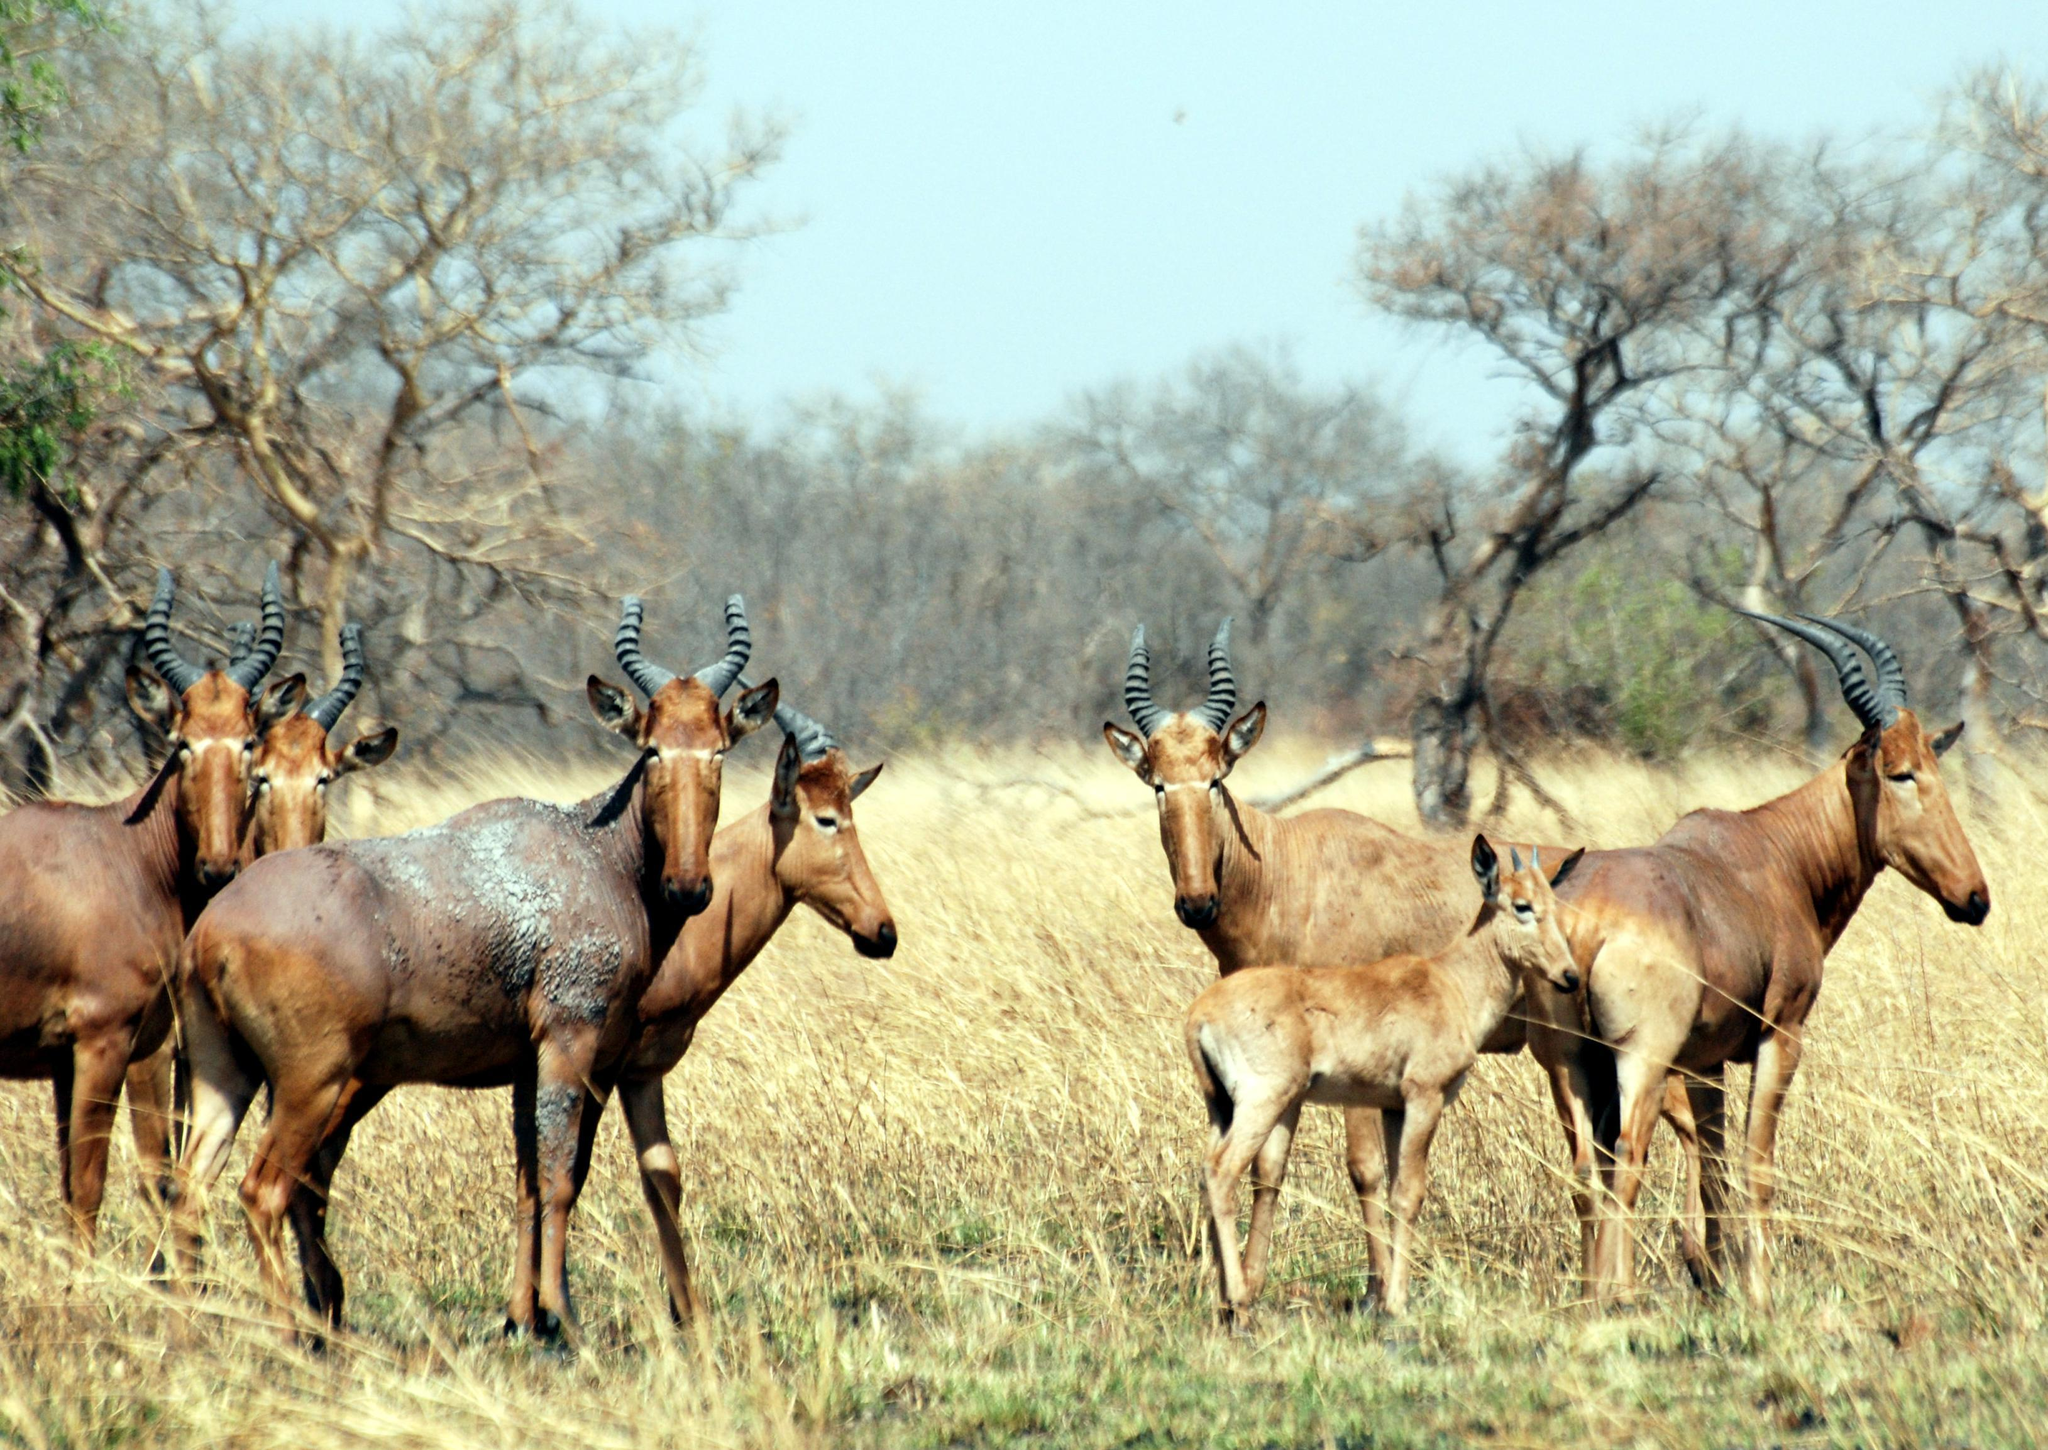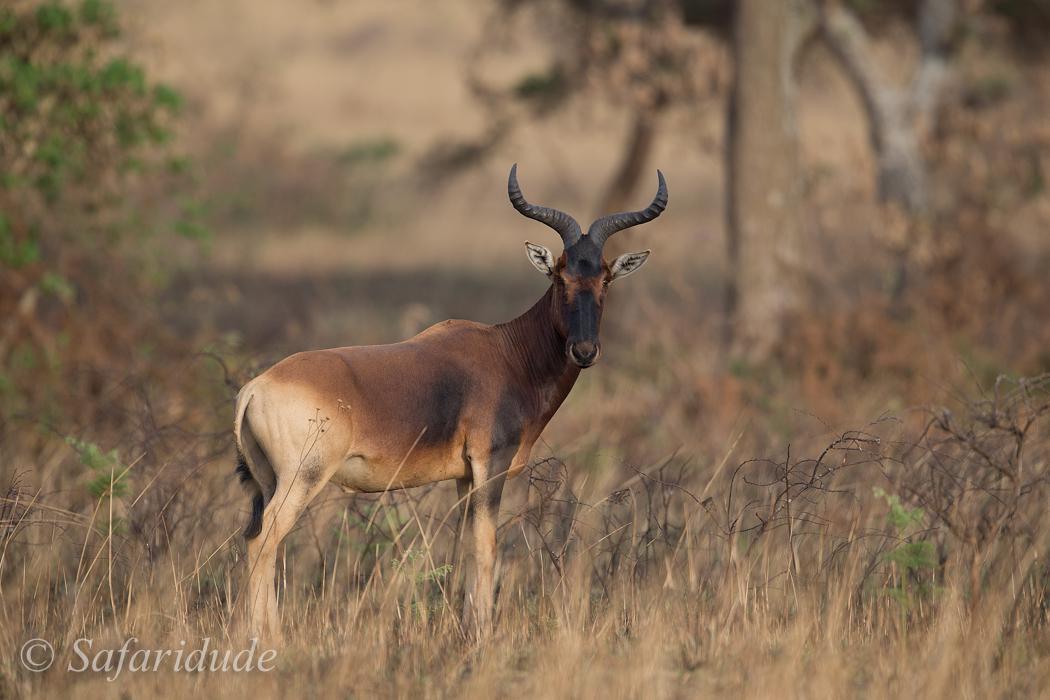The first image is the image on the left, the second image is the image on the right. Evaluate the accuracy of this statement regarding the images: "There are more then six of these antelope-like creatures.". Is it true? Answer yes or no. Yes. The first image is the image on the left, the second image is the image on the right. Evaluate the accuracy of this statement regarding the images: "The right image contains one horned animal with its body turned rightward, and the left image contains at least five horned animals.". Is it true? Answer yes or no. Yes. 